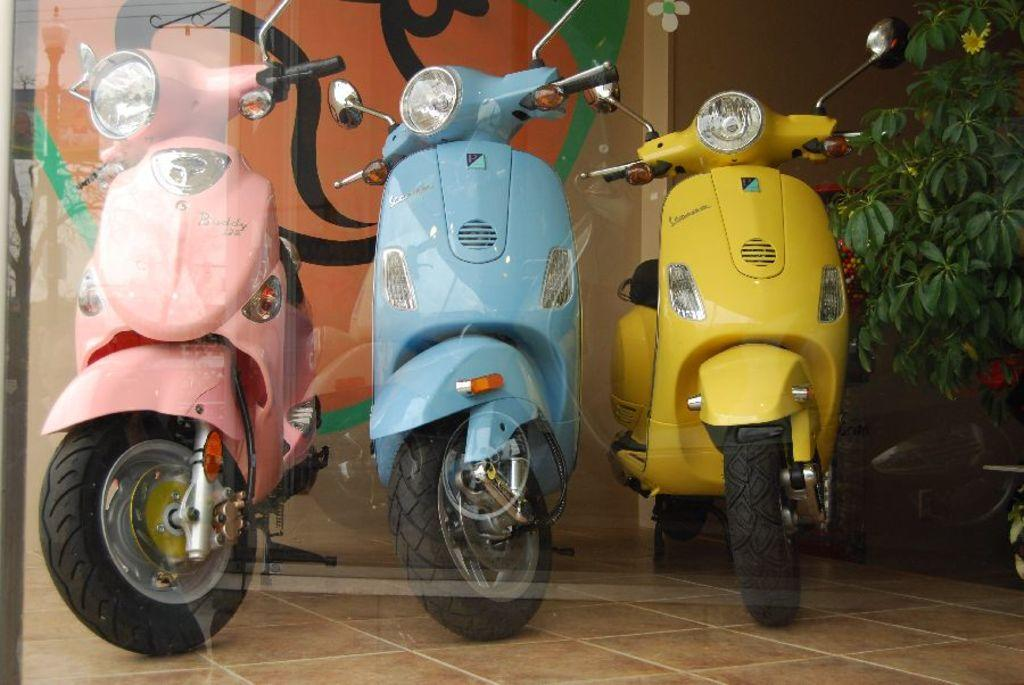How many vehicles are in the image? There are three vehicles in the image. What colors are the vehicles? The vehicles are in pink, blue, and yellow colors. What can be seen in the background of the image? There are plants and a multi-color wall in the background of the image. What color are the plants? The plants are green. What song is being played on the record in the image? There is no record present in the image, so it is not possible to determine what song might be playing. 